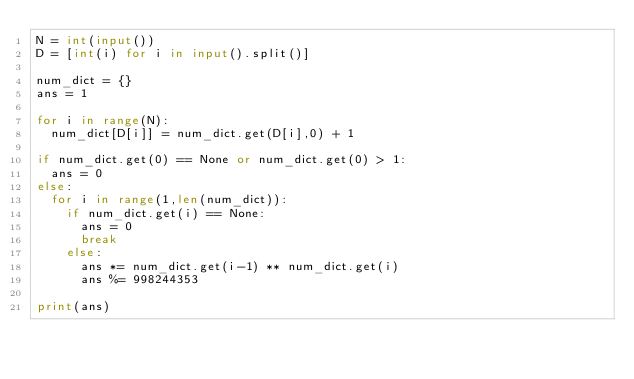<code> <loc_0><loc_0><loc_500><loc_500><_Python_>N = int(input())
D = [int(i) for i in input().split()]

num_dict = {}
ans = 1

for i in range(N):
  num_dict[D[i]] = num_dict.get(D[i],0) + 1

if num_dict.get(0) == None or num_dict.get(0) > 1:
  ans = 0
else:
  for i in range(1,len(num_dict)):
    if num_dict.get(i) == None:
      ans = 0
      break
    else:
      ans *= num_dict.get(i-1) ** num_dict.get(i)
      ans %= 998244353

print(ans)
</code> 